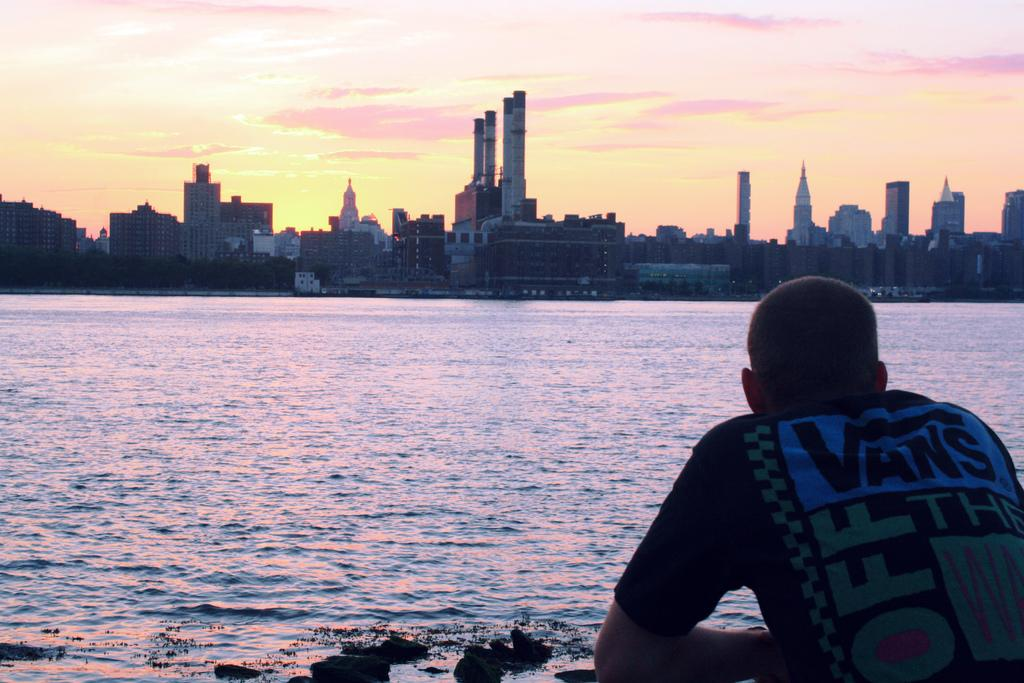Who or what is on the right side of the image? There is a person on the right side of the image. What is the primary element visible in the image? Water is visible in the image. What can be seen in the background of the image? There are buildings and the sky visible in the background of the image. What type of kettle is being used by the passenger in the image? There is no kettle or passenger present in the image. 